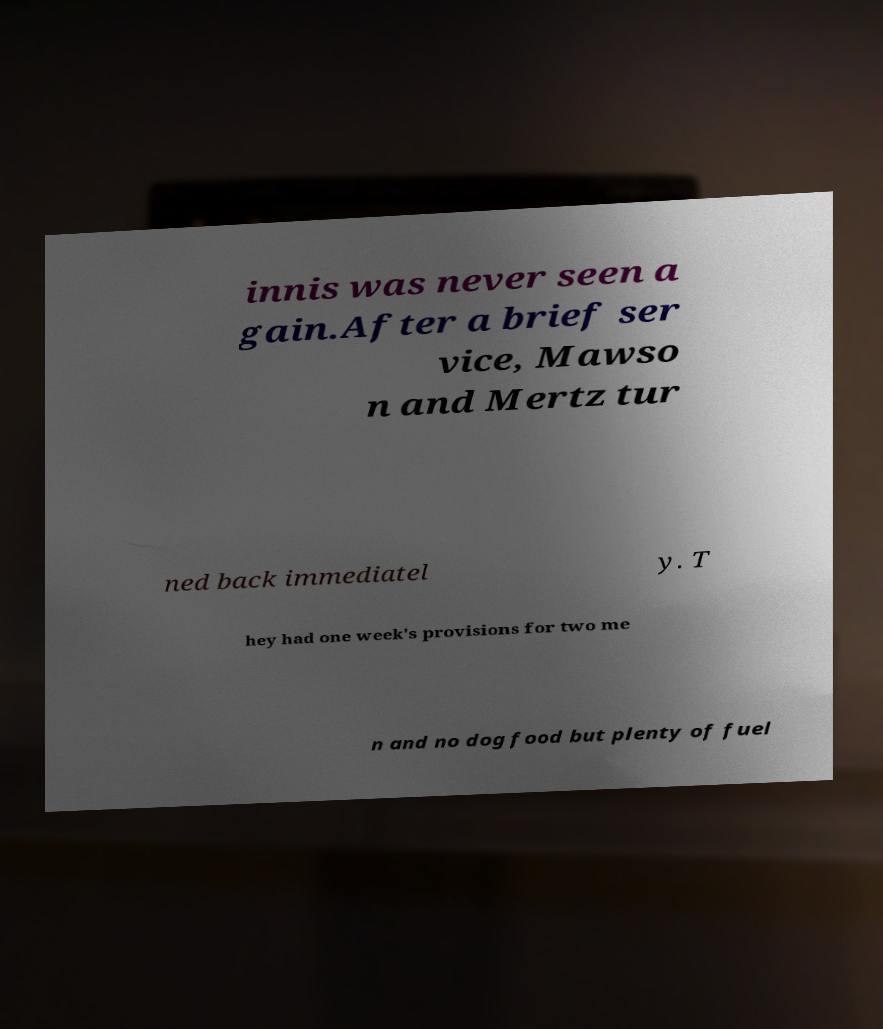I need the written content from this picture converted into text. Can you do that? innis was never seen a gain.After a brief ser vice, Mawso n and Mertz tur ned back immediatel y. T hey had one week's provisions for two me n and no dog food but plenty of fuel 